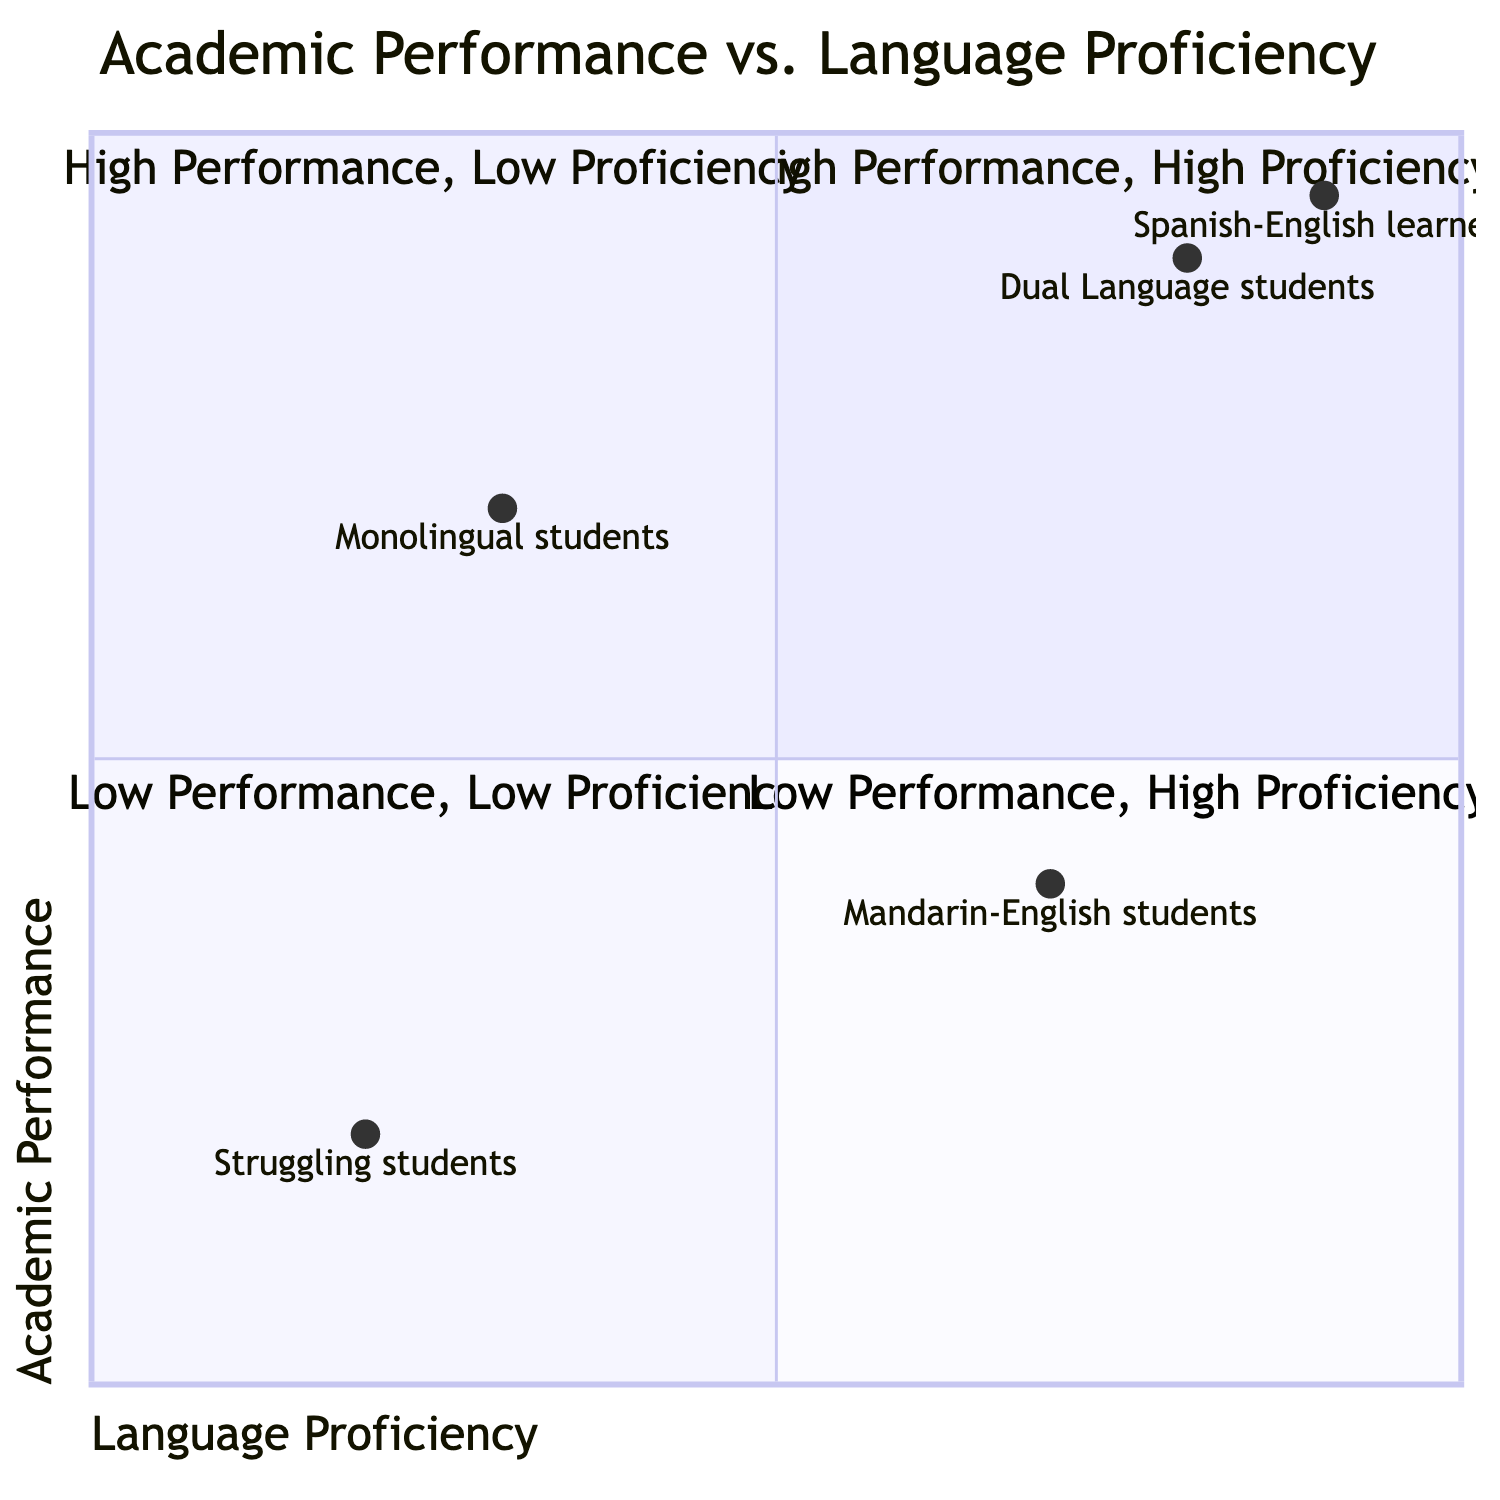What quadrant contains Dual Language students with high academic skills? Dual Language students demonstrating excellent academic skills fall into the "High Performance, High Proficiency" quadrant, as it describes those who excel academically while possessing strong language skills.
Answer: High Performance, High Proficiency Which quadrant has students with high academic performance but low language proficiency? The quadrant labeled "High Performance, Low Proficiency" represents students who achieve high academic scores while lacking proficiency in a second language, which specifically describes monolingual students.
Answer: High Performance, Low Proficiency How many student groups are represented in the diagram? The diagram includes four distinct student groups: Dual Language students, Monolingual students, Spanish-English learners, and Mandarin-English students. Each group is represented by specific data points reflecting their proficiency and performance.
Answer: Four What is the performance level of Mandarin-English students? Looking at the data for Mandarin-English students, they have a proficiency score of 0.7 and an academic performance score of 0.4, which places them in the "Low Performance, High Proficiency" quadrant.
Answer: Low Performance, High Proficiency What is the distinguishing feature of the "Low Performance, Low Proficiency" quadrant? The "Low Performance, Low Proficiency" quadrant is characterized by students who struggle both academically and in language acquisition, indicating they are behind in both areas. Examples include students with low scores in reading and writing, denoting their overall difficulties.
Answer: Students struggling both academically and with language acquisition Which student group is represented in the "High Performance, Low Proficiency" quadrant? Monolingual students are represented in the "High Performance, Low Proficiency" quadrant, as they achieve high academic scores while displaying low proficiency in a second language.
Answer: Monolingual students What are the two quadrants where Dual Language students can be found? The two quadrants where Dual Language students might be found are "High Performance, High Proficiency" for those excelling academically with strong language skills, and "Low Performance, High Proficiency" for those fluent in their second language but not meeting academic benchmarks.
Answer: High Performance, High Proficiency; Low Performance, High Proficiency Which student group is at the bottom left quadrant? The "Low Performance, Low Proficiency" quadrant represents students who are behind in academic performance and weak in language skills, indicating it includes both monolingual and dual language students struggling in both areas.
Answer: Struggling students 